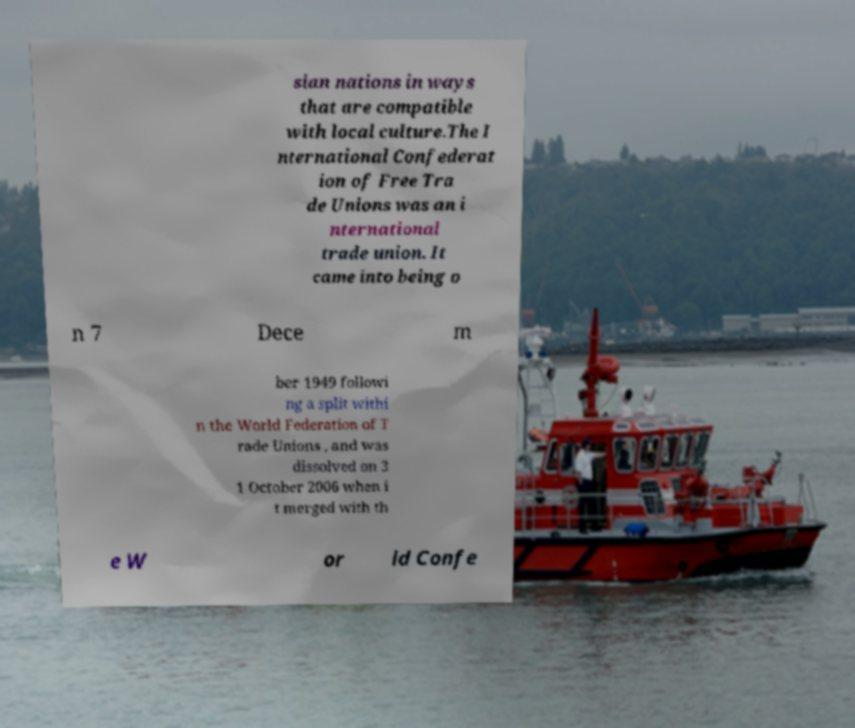I need the written content from this picture converted into text. Can you do that? sian nations in ways that are compatible with local culture.The I nternational Confederat ion of Free Tra de Unions was an i nternational trade union. It came into being o n 7 Dece m ber 1949 followi ng a split withi n the World Federation of T rade Unions , and was dissolved on 3 1 October 2006 when i t merged with th e W or ld Confe 